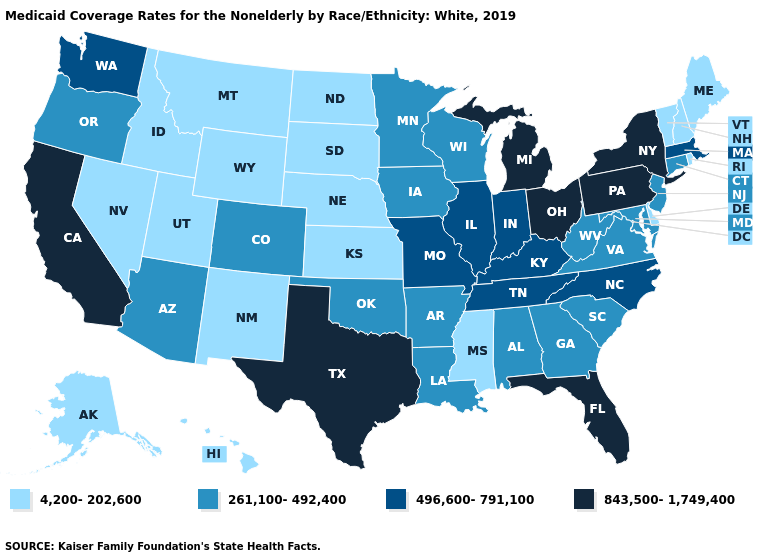Does Montana have the lowest value in the USA?
Quick response, please. Yes. What is the value of Alabama?
Concise answer only. 261,100-492,400. What is the lowest value in the USA?
Give a very brief answer. 4,200-202,600. What is the highest value in the USA?
Be succinct. 843,500-1,749,400. What is the value of Iowa?
Be succinct. 261,100-492,400. Does Tennessee have the lowest value in the USA?
Write a very short answer. No. Does Michigan have the highest value in the MidWest?
Write a very short answer. Yes. Does Texas have the highest value in the South?
Keep it brief. Yes. Name the states that have a value in the range 843,500-1,749,400?
Write a very short answer. California, Florida, Michigan, New York, Ohio, Pennsylvania, Texas. What is the highest value in the USA?
Give a very brief answer. 843,500-1,749,400. Which states hav the highest value in the Northeast?
Keep it brief. New York, Pennsylvania. Does the map have missing data?
Quick response, please. No. Which states have the highest value in the USA?
Concise answer only. California, Florida, Michigan, New York, Ohio, Pennsylvania, Texas. How many symbols are there in the legend?
Quick response, please. 4. Among the states that border South Carolina , does Georgia have the highest value?
Give a very brief answer. No. 